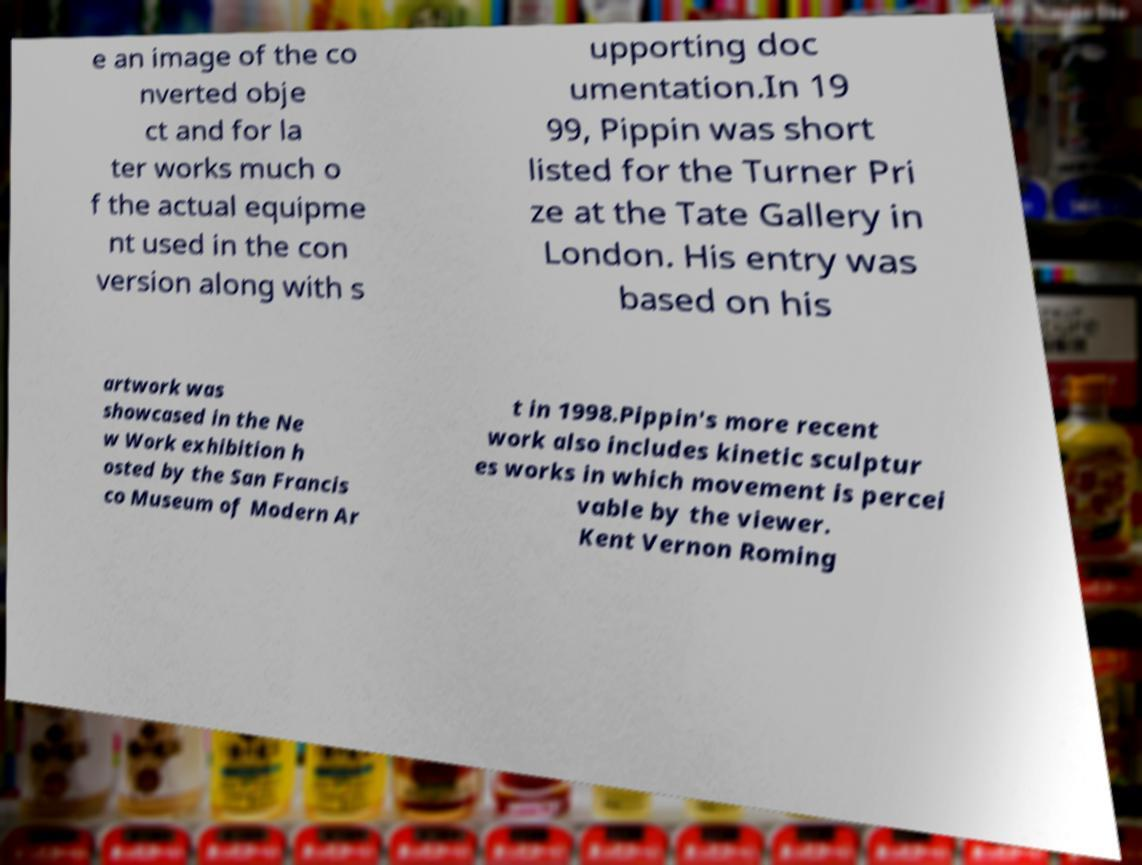Can you accurately transcribe the text from the provided image for me? e an image of the co nverted obje ct and for la ter works much o f the actual equipme nt used in the con version along with s upporting doc umentation.In 19 99, Pippin was short listed for the Turner Pri ze at the Tate Gallery in London. His entry was based on his artwork was showcased in the Ne w Work exhibition h osted by the San Francis co Museum of Modern Ar t in 1998.Pippin's more recent work also includes kinetic sculptur es works in which movement is percei vable by the viewer. Kent Vernon Roming 